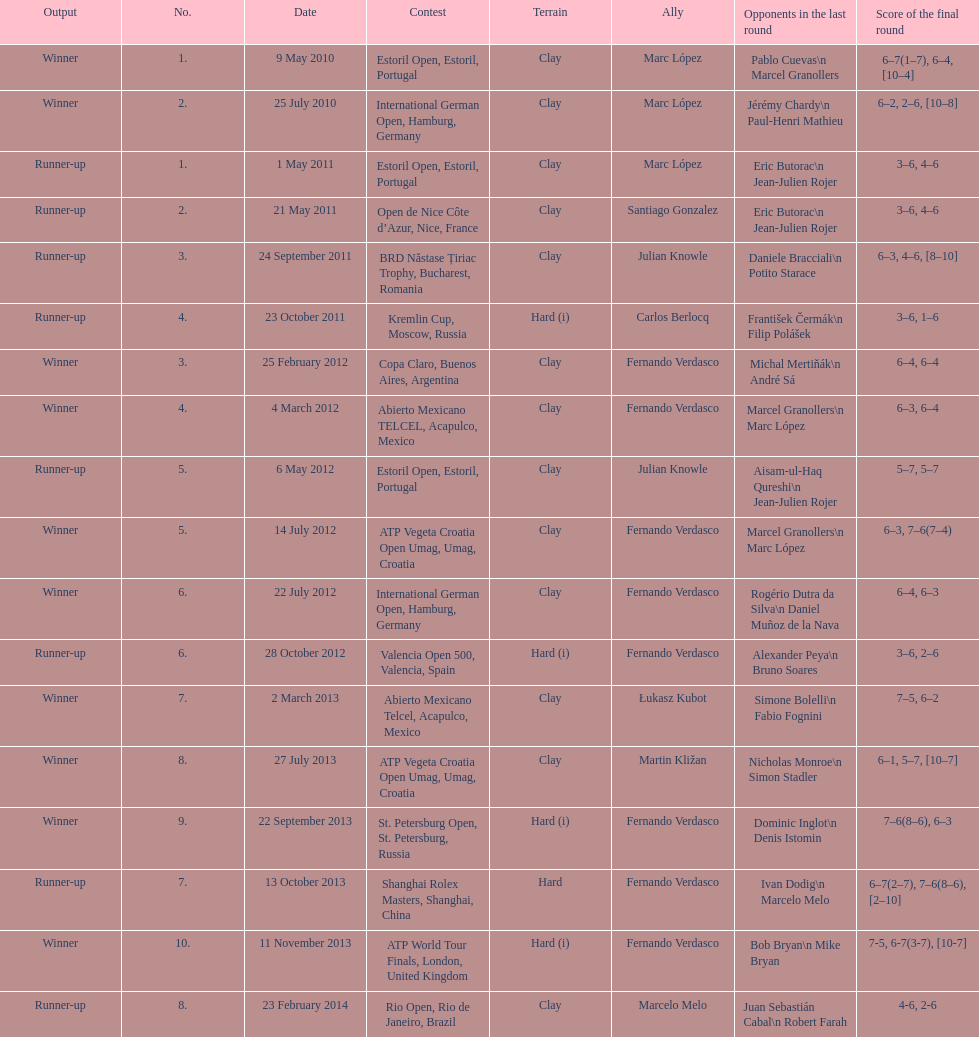How many runner-ups at most are listed? 8. 